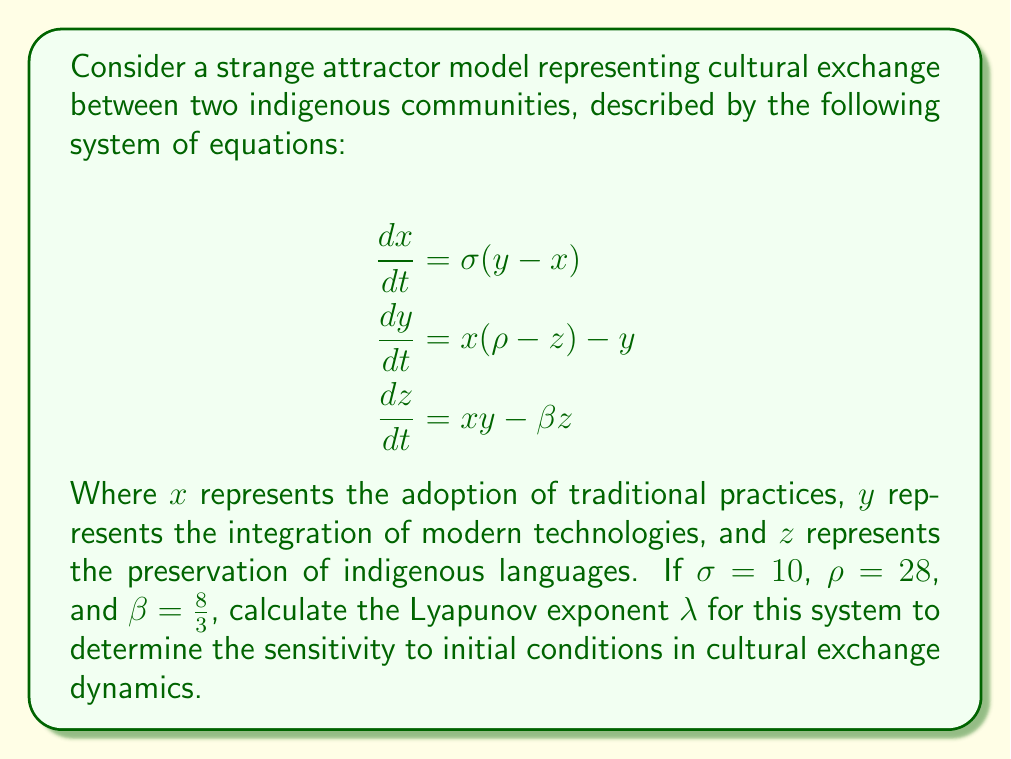Can you solve this math problem? To calculate the Lyapunov exponent for this strange attractor model of cultural exchange, we'll follow these steps:

1. Recognize that this system is the Lorenz attractor, a well-known strange attractor in chaos theory.

2. For the Lorenz system, the Lyapunov exponent can be approximated using the formula:

   $$\lambda \approx 0.9056(\sigma - 1)$$

3. Substitute the given value of $\sigma = 10$ into the formula:

   $$\lambda \approx 0.9056(10 - 1)$$

4. Simplify:
   
   $$\lambda \approx 0.9056 \times 9$$

5. Calculate the final result:

   $$\lambda \approx 8.1504$$

This positive Lyapunov exponent indicates that the cultural exchange dynamics between the two indigenous communities are chaotic and highly sensitive to initial conditions. Small changes in initial cultural practices, technology adoption, or language preservation efforts can lead to significantly different outcomes over time.

For policy-making in the Ministry of Culture and Indigenous Affairs, this result suggests that interventions should be carefully considered and continuously monitored, as their effects may be unpredictable and far-reaching in the long term.
Answer: $\lambda \approx 8.1504$ 